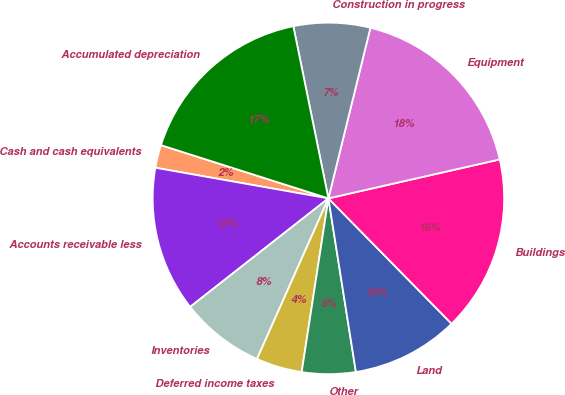<chart> <loc_0><loc_0><loc_500><loc_500><pie_chart><fcel>Cash and cash equivalents<fcel>Accounts receivable less<fcel>Inventories<fcel>Deferred income taxes<fcel>Other<fcel>Land<fcel>Buildings<fcel>Equipment<fcel>Construction in progress<fcel>Accumulated depreciation<nl><fcel>2.11%<fcel>13.38%<fcel>7.75%<fcel>4.23%<fcel>4.93%<fcel>9.86%<fcel>16.2%<fcel>17.6%<fcel>7.04%<fcel>16.9%<nl></chart> 